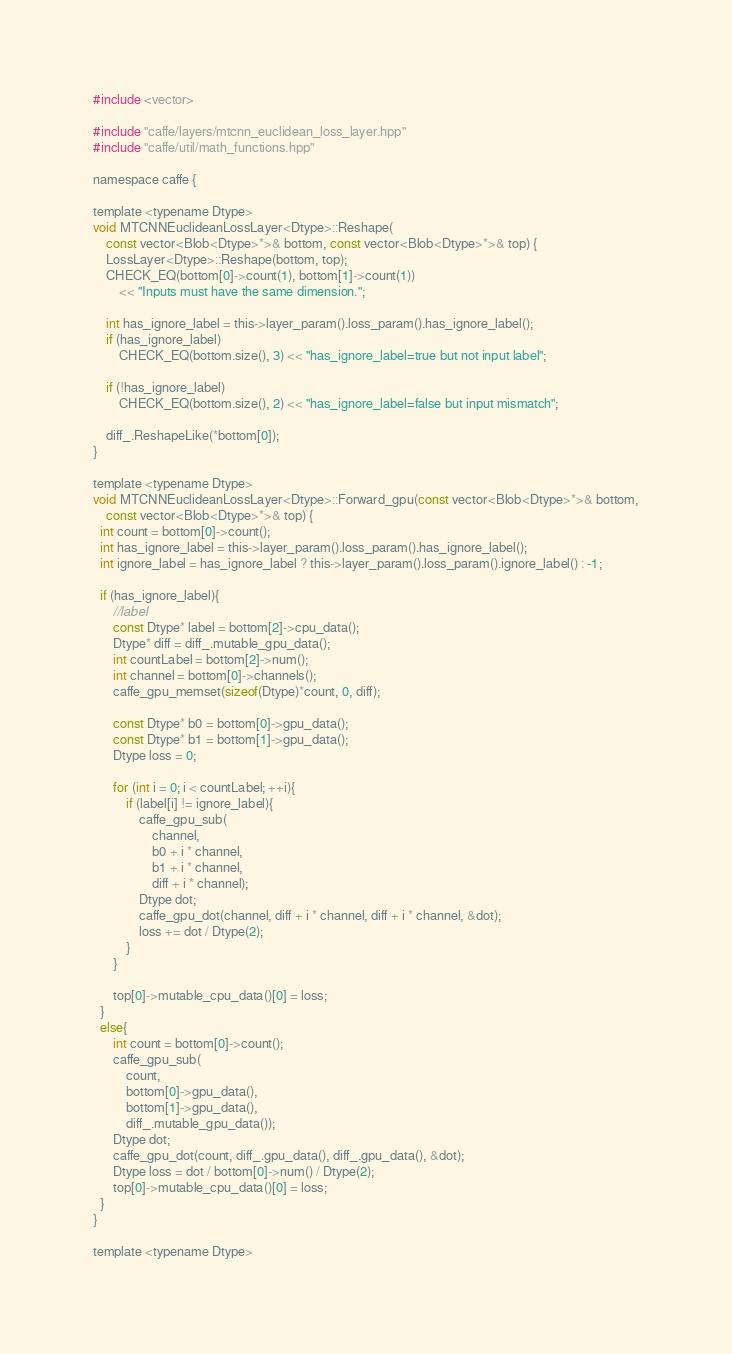Convert code to text. <code><loc_0><loc_0><loc_500><loc_500><_Cuda_>#include <vector>

#include "caffe/layers/mtcnn_euclidean_loss_layer.hpp"
#include "caffe/util/math_functions.hpp"

namespace caffe {

template <typename Dtype>
void MTCNNEuclideanLossLayer<Dtype>::Reshape(
	const vector<Blob<Dtype>*>& bottom, const vector<Blob<Dtype>*>& top) {
	LossLayer<Dtype>::Reshape(bottom, top);
	CHECK_EQ(bottom[0]->count(1), bottom[1]->count(1))
		<< "Inputs must have the same dimension.";
	 
	int has_ignore_label = this->layer_param().loss_param().has_ignore_label();
	if (has_ignore_label)
		CHECK_EQ(bottom.size(), 3) << "has_ignore_label=true but not input label";
	
	if (!has_ignore_label)
		CHECK_EQ(bottom.size(), 2) << "has_ignore_label=false but input mismatch";

	diff_.ReshapeLike(*bottom[0]);
}

template <typename Dtype>
void MTCNNEuclideanLossLayer<Dtype>::Forward_gpu(const vector<Blob<Dtype>*>& bottom,
    const vector<Blob<Dtype>*>& top) {
  int count = bottom[0]->count();
  int has_ignore_label = this->layer_param().loss_param().has_ignore_label();
  int ignore_label = has_ignore_label ? this->layer_param().loss_param().ignore_label() : -1;

  if (has_ignore_label){
	  //label
	  const Dtype* label = bottom[2]->cpu_data();
	  Dtype* diff = diff_.mutable_gpu_data();
	  int countLabel = bottom[2]->num();
	  int channel = bottom[0]->channels();
	  caffe_gpu_memset(sizeof(Dtype)*count, 0, diff);

	  const Dtype* b0 = bottom[0]->gpu_data();
	  const Dtype* b1 = bottom[1]->gpu_data();
	  Dtype loss = 0;

	  for (int i = 0; i < countLabel; ++i){
		  if (label[i] != ignore_label){
			  caffe_gpu_sub(
				  channel,
				  b0 + i * channel,
				  b1 + i * channel,
				  diff + i * channel);
			  Dtype dot;
			  caffe_gpu_dot(channel, diff + i * channel, diff + i * channel, &dot);
			  loss += dot / Dtype(2);
		  }
	  }

	  top[0]->mutable_cpu_data()[0] = loss;
  }
  else{
	  int count = bottom[0]->count();
	  caffe_gpu_sub(
		  count,
		  bottom[0]->gpu_data(),
		  bottom[1]->gpu_data(),
		  diff_.mutable_gpu_data());
	  Dtype dot;
	  caffe_gpu_dot(count, diff_.gpu_data(), diff_.gpu_data(), &dot);
	  Dtype loss = dot / bottom[0]->num() / Dtype(2);
	  top[0]->mutable_cpu_data()[0] = loss;
  }
}

template <typename Dtype></code> 